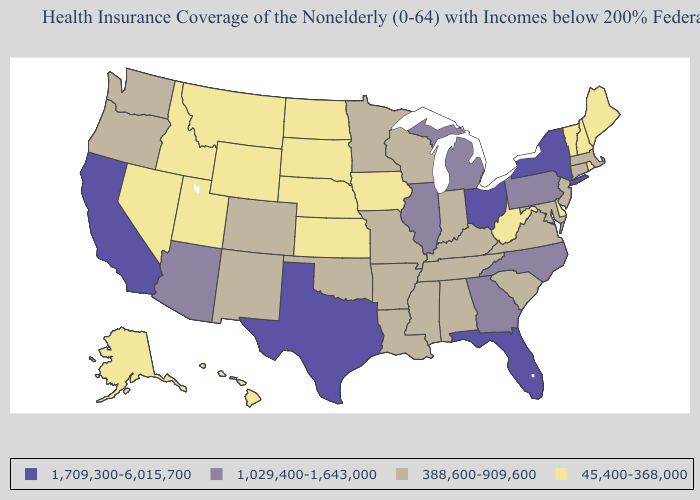Name the states that have a value in the range 1,709,300-6,015,700?
Be succinct. California, Florida, New York, Ohio, Texas. What is the highest value in states that border New Mexico?
Keep it brief. 1,709,300-6,015,700. Does Iowa have the lowest value in the USA?
Answer briefly. Yes. Name the states that have a value in the range 1,029,400-1,643,000?
Concise answer only. Arizona, Georgia, Illinois, Michigan, North Carolina, Pennsylvania. What is the value of New York?
Answer briefly. 1,709,300-6,015,700. What is the highest value in the USA?
Answer briefly. 1,709,300-6,015,700. Name the states that have a value in the range 1,029,400-1,643,000?
Short answer required. Arizona, Georgia, Illinois, Michigan, North Carolina, Pennsylvania. Among the states that border Alabama , which have the lowest value?
Quick response, please. Mississippi, Tennessee. Name the states that have a value in the range 45,400-368,000?
Be succinct. Alaska, Delaware, Hawaii, Idaho, Iowa, Kansas, Maine, Montana, Nebraska, Nevada, New Hampshire, North Dakota, Rhode Island, South Dakota, Utah, Vermont, West Virginia, Wyoming. What is the highest value in the Northeast ?
Answer briefly. 1,709,300-6,015,700. Among the states that border Minnesota , which have the lowest value?
Answer briefly. Iowa, North Dakota, South Dakota. Does North Carolina have the lowest value in the South?
Quick response, please. No. What is the highest value in the USA?
Answer briefly. 1,709,300-6,015,700. Does Utah have the lowest value in the USA?
Short answer required. Yes. Name the states that have a value in the range 1,029,400-1,643,000?
Concise answer only. Arizona, Georgia, Illinois, Michigan, North Carolina, Pennsylvania. 